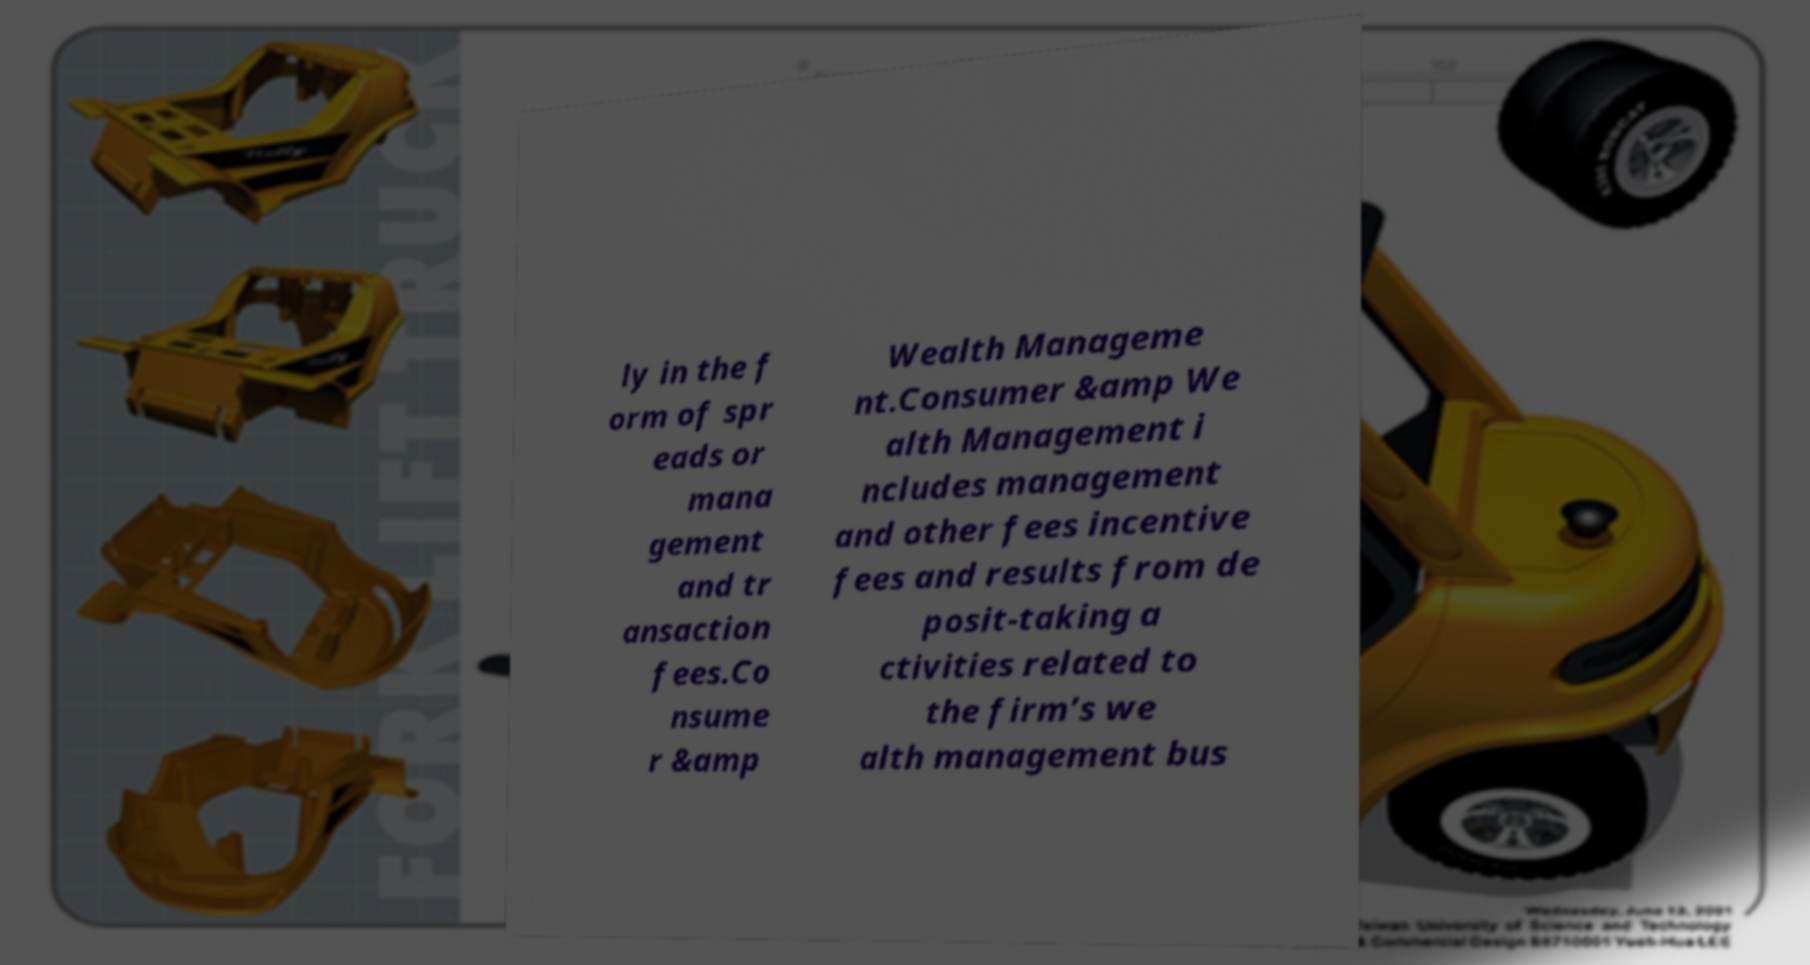Please read and relay the text visible in this image. What does it say? ly in the f orm of spr eads or mana gement and tr ansaction fees.Co nsume r &amp Wealth Manageme nt.Consumer &amp We alth Management i ncludes management and other fees incentive fees and results from de posit-taking a ctivities related to the firm’s we alth management bus 